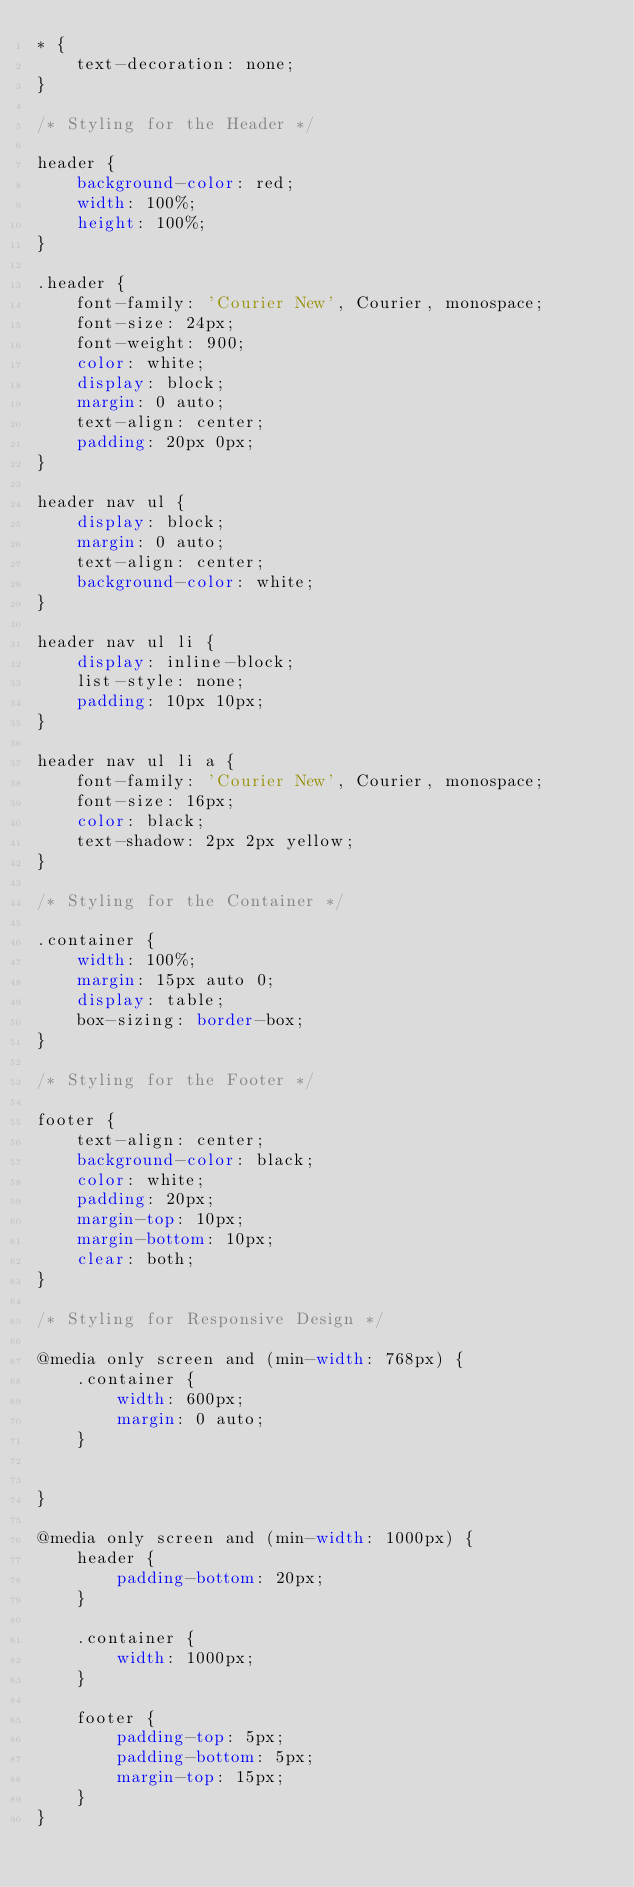<code> <loc_0><loc_0><loc_500><loc_500><_CSS_>* {
    text-decoration: none;
}

/* Styling for the Header */

header {
    background-color: red;
    width: 100%;
    height: 100%;
}

.header {
    font-family: 'Courier New', Courier, monospace;
    font-size: 24px;
    font-weight: 900;
    color: white;
    display: block;
    margin: 0 auto;
    text-align: center;
    padding: 20px 0px;
}

header nav ul {
    display: block;
    margin: 0 auto;
    text-align: center;
    background-color: white;
}

header nav ul li {
    display: inline-block;
    list-style: none;
    padding: 10px 10px;
}

header nav ul li a {
    font-family: 'Courier New', Courier, monospace;
    font-size: 16px;
    color: black;
    text-shadow: 2px 2px yellow;
}

/* Styling for the Container */

.container {
    width: 100%;
    margin: 15px auto 0;
    display: table;
    box-sizing: border-box;
}

/* Styling for the Footer */

footer {
    text-align: center;
    background-color: black;
    color: white;
    padding: 20px;
    margin-top: 10px;
    margin-bottom: 10px;
    clear: both;
}

/* Styling for Responsive Design */

@media only screen and (min-width: 768px) {
    .container {
        width: 600px;
        margin: 0 auto;
    }


}

@media only screen and (min-width: 1000px) {
    header {
        padding-bottom: 20px;
    }

    .container {
        width: 1000px;
    }
    
    footer {
        padding-top: 5px;
        padding-bottom: 5px;
        margin-top: 15px;
    }
}</code> 